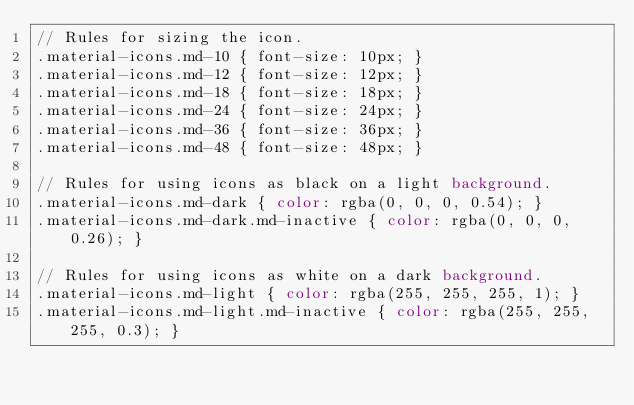<code> <loc_0><loc_0><loc_500><loc_500><_CSS_>// Rules for sizing the icon.
.material-icons.md-10 { font-size: 10px; }
.material-icons.md-12 { font-size: 12px; }
.material-icons.md-18 { font-size: 18px; }
.material-icons.md-24 { font-size: 24px; }
.material-icons.md-36 { font-size: 36px; }
.material-icons.md-48 { font-size: 48px; }

// Rules for using icons as black on a light background.
.material-icons.md-dark { color: rgba(0, 0, 0, 0.54); }
.material-icons.md-dark.md-inactive { color: rgba(0, 0, 0, 0.26); }

// Rules for using icons as white on a dark background.
.material-icons.md-light { color: rgba(255, 255, 255, 1); }
.material-icons.md-light.md-inactive { color: rgba(255, 255, 255, 0.3); }</code> 